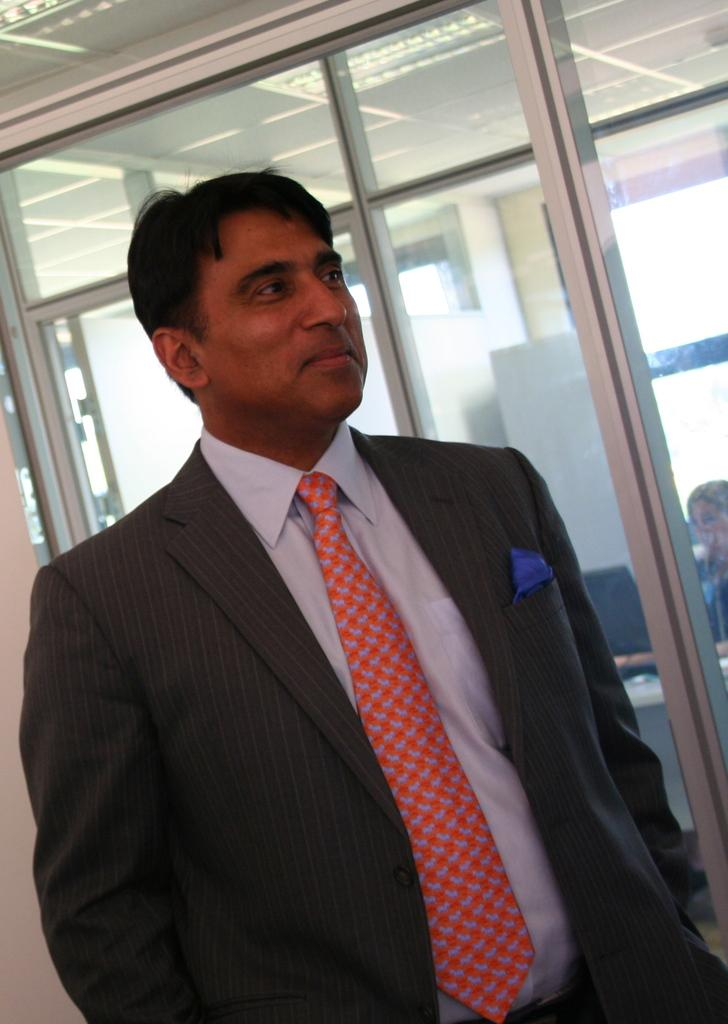What is present in the image? There is a person in the image. How is the person's facial expression? The person has a smiling face. What type of architectural feature is visible in the image? There is a glass door visible in the image. How many earths can be seen in the image? There are no earths present in the image. What type of point is the person standing on in the image? There is no specific point mentioned in the image, and the person's legs are not visible to determine if they are standing on a point. 